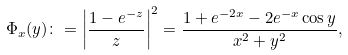<formula> <loc_0><loc_0><loc_500><loc_500>\Phi _ { x } ( y ) \colon = \left | \frac { 1 - e ^ { - z } } { z } \right | ^ { 2 } = \frac { 1 + e ^ { - 2 x } - 2 e ^ { - x } \cos y } { x ^ { 2 } + y ^ { 2 } } ,</formula> 